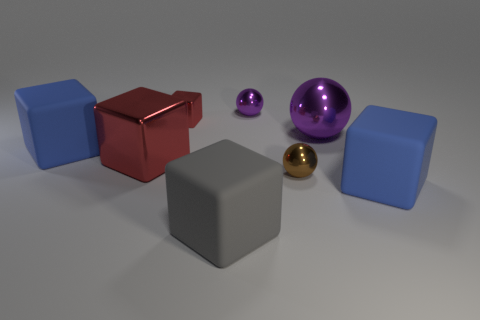Subtract all small metallic cubes. How many cubes are left? 4 Subtract all gray cubes. How many cubes are left? 4 Add 1 big gray rubber blocks. How many objects exist? 9 Subtract all cyan blocks. Subtract all blue cylinders. How many blocks are left? 5 Subtract all spheres. How many objects are left? 5 Subtract all spheres. Subtract all large blue things. How many objects are left? 3 Add 7 large blue cubes. How many large blue cubes are left? 9 Add 6 gray objects. How many gray objects exist? 7 Subtract 0 yellow cylinders. How many objects are left? 8 